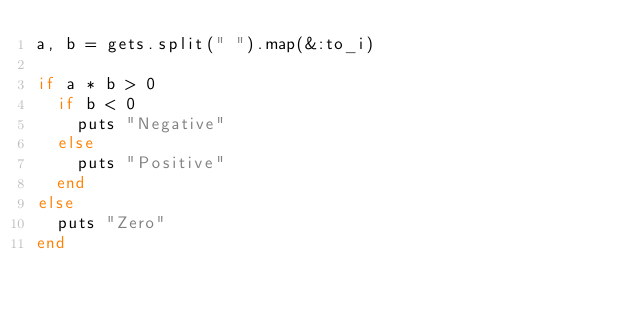<code> <loc_0><loc_0><loc_500><loc_500><_Ruby_>a, b = gets.split(" ").map(&:to_i)

if a * b > 0
  if b < 0
    puts "Negative"
  else
    puts "Positive"
  end
else
  puts "Zero"
end
</code> 